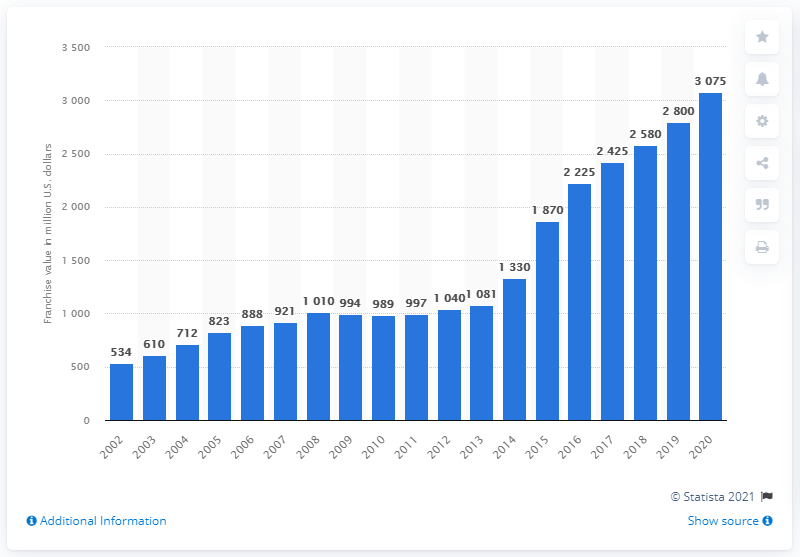Draw attention to some important aspects in this diagram. In 2020, the franchise value of the Seattle Seahawks was 3075. 